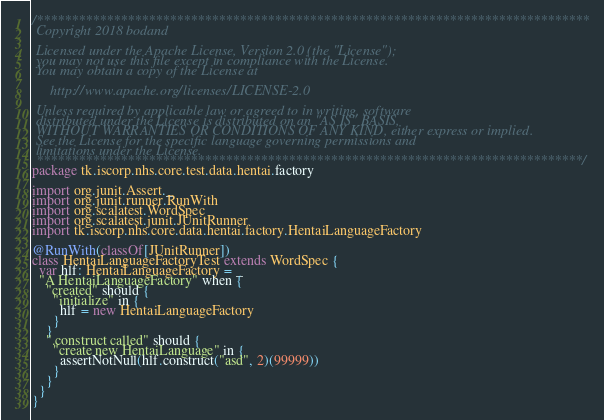Convert code to text. <code><loc_0><loc_0><loc_500><loc_500><_Scala_>/*******************************************************************************
 Copyright 2018 bodand

 Licensed under the Apache License, Version 2.0 (the "License");
 you may not use this file except in compliance with the License.
 You may obtain a copy of the License at

     http://www.apache.org/licenses/LICENSE-2.0

 Unless required by applicable law or agreed to in writing, software
 distributed under the License is distributed on an "AS IS" BASIS,
 WITHOUT WARRANTIES OR CONDITIONS OF ANY KIND, either express or implied.
 See the License for the specific language governing permissions and
 limitations under the License.
 ******************************************************************************/
package tk.iscorp.nhs.core.test.data.hentai.factory

import org.junit.Assert._
import org.junit.runner.RunWith
import org.scalatest.WordSpec
import org.scalatest.junit.JUnitRunner
import tk.iscorp.nhs.core.data.hentai.factory.HentaiLanguageFactory

@RunWith(classOf[JUnitRunner])
class HentaiLanguageFactoryTest extends WordSpec {
  var hlf: HentaiLanguageFactory = _
  "A HentaiLanguageFactory" when {
    "created" should {
      "initialize" in {
        hlf = new HentaiLanguageFactory
      }
    }
    ".construct called" should {
      "create new HentaiLanguage" in {
        assertNotNull(hlf.construct("asd", 2)(99999))
      }
    }
  }
}
</code> 